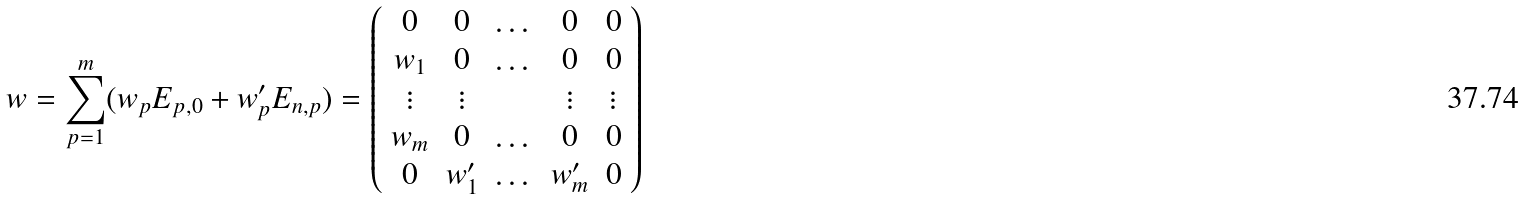<formula> <loc_0><loc_0><loc_500><loc_500>w = \sum _ { p = 1 } ^ { m } ( w _ { p } E _ { p , 0 } + w _ { p } ^ { \prime } E _ { n , p } ) = \left ( \begin{array} { c c c c c } 0 & 0 & \dots & 0 & 0 \\ w _ { 1 } & 0 & \dots & 0 & 0 \\ \vdots & \vdots & & \vdots & \vdots \\ w _ { m } & 0 & \dots & 0 & 0 \\ 0 & w ^ { \prime } _ { 1 } & \dots & w ^ { \prime } _ { m } & 0 \end{array} \right )</formula> 